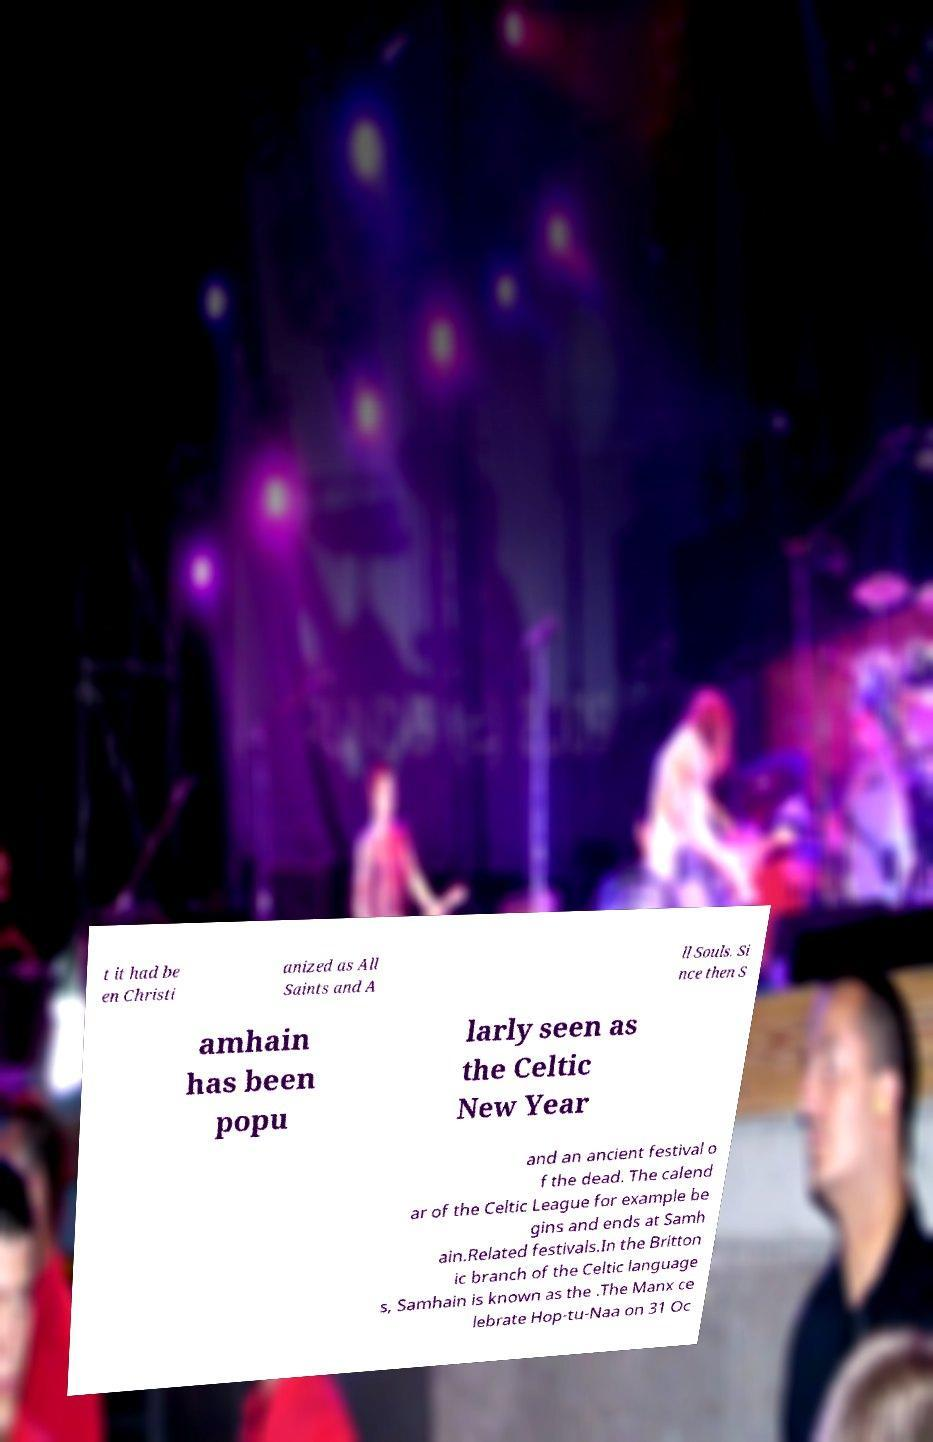For documentation purposes, I need the text within this image transcribed. Could you provide that? t it had be en Christi anized as All Saints and A ll Souls. Si nce then S amhain has been popu larly seen as the Celtic New Year and an ancient festival o f the dead. The calend ar of the Celtic League for example be gins and ends at Samh ain.Related festivals.In the Britton ic branch of the Celtic language s, Samhain is known as the .The Manx ce lebrate Hop-tu-Naa on 31 Oc 